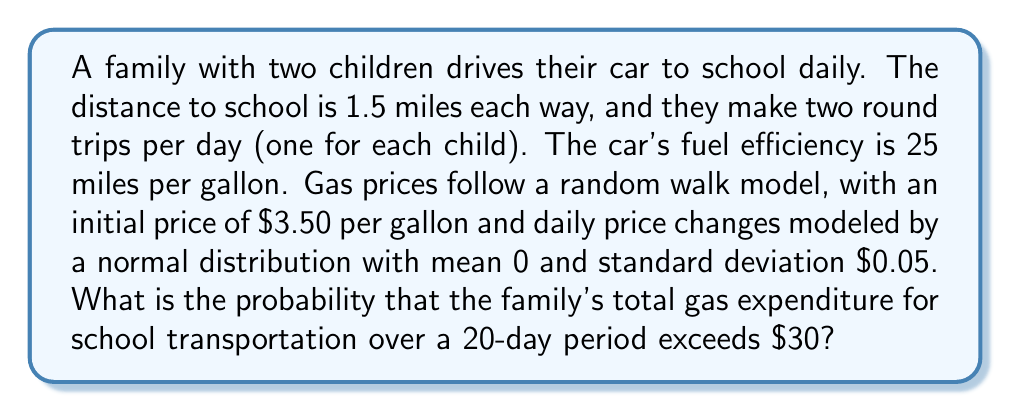Could you help me with this problem? Let's approach this step-by-step:

1) First, calculate the total distance driven for school transportation daily:
   $$(1.5 \text{ miles} \times 2 \text{ trips}) \times 2 \text{ children} = 6 \text{ miles per day}$$

2) Calculate the gas consumption per day:
   $$\frac{6 \text{ miles}}{25 \text{ miles/gallon}} = 0.24 \text{ gallons per day}$$

3) Over 20 days, the total gas consumption is:
   $$0.24 \text{ gallons/day} \times 20 \text{ days} = 4.8 \text{ gallons}$$

4) The gas price follows a random walk. After 20 days, the price will be normally distributed with:
   - Mean: $\mu = 3.50$ (initial price)
   - Standard deviation: $\sigma = 0.05 \sqrt{20} = 0.2236$

5) Let $X$ be the random variable representing the gas price after 20 days. Then:
   $$X \sim N(3.50, 0.2236^2)$$

6) The total expenditure $Y$ is $4.8X$. Therefore:
   $$Y \sim N(4.8 \times 3.50, (4.8 \times 0.2236)^2)$$
   $$Y \sim N(16.80, 1.1533^2)$$

7) We want to find $P(Y > 30)$. Standardizing:
   $$P(Y > 30) = P\left(\frac{Y - 16.80}{1.1533} > \frac{30 - 16.80}{1.1533}\right)$$
   $$= P(Z > 11.44)$$

8) Using a standard normal table or calculator:
   $$P(Z > 11.44) \approx 0$$

Therefore, the probability is essentially 0.
Answer: $\approx 0$ 